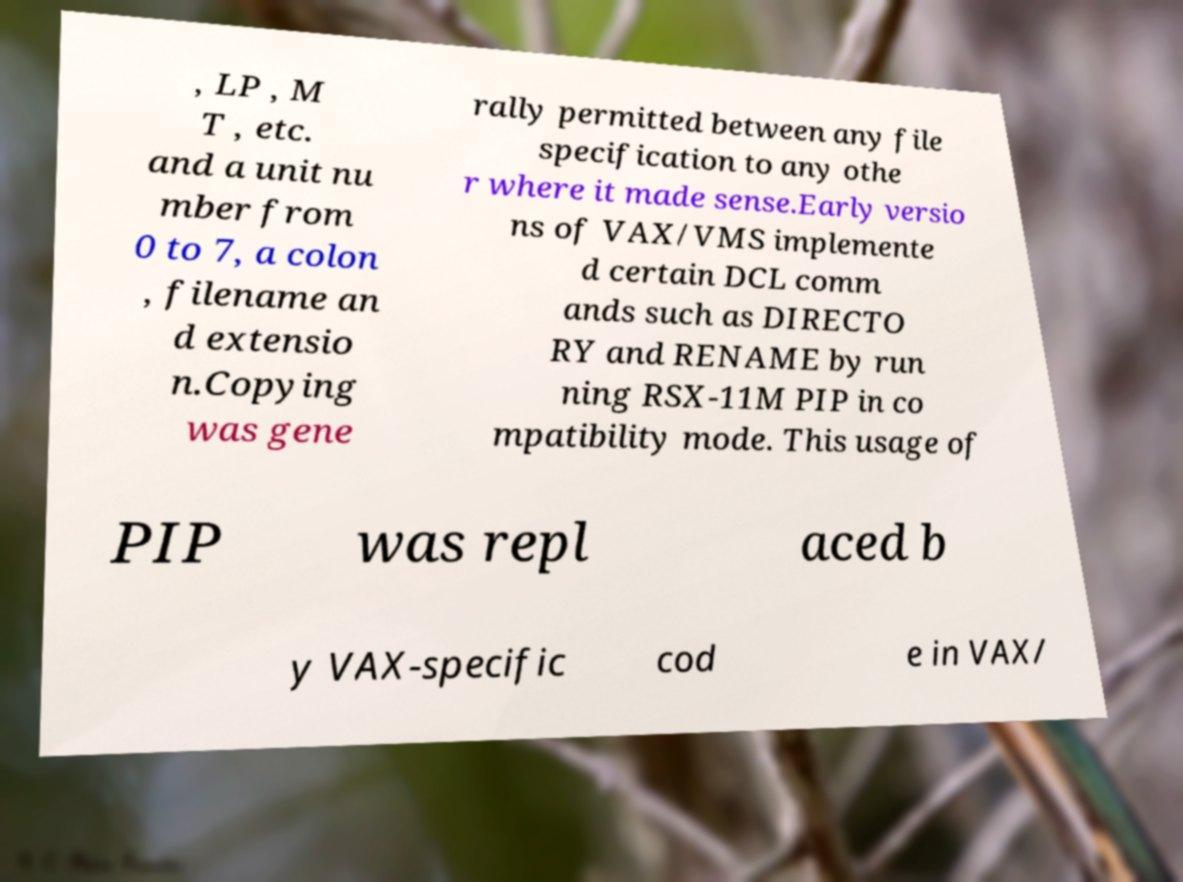Can you accurately transcribe the text from the provided image for me? , LP , M T , etc. and a unit nu mber from 0 to 7, a colon , filename an d extensio n.Copying was gene rally permitted between any file specification to any othe r where it made sense.Early versio ns of VAX/VMS implemente d certain DCL comm ands such as DIRECTO RY and RENAME by run ning RSX-11M PIP in co mpatibility mode. This usage of PIP was repl aced b y VAX-specific cod e in VAX/ 